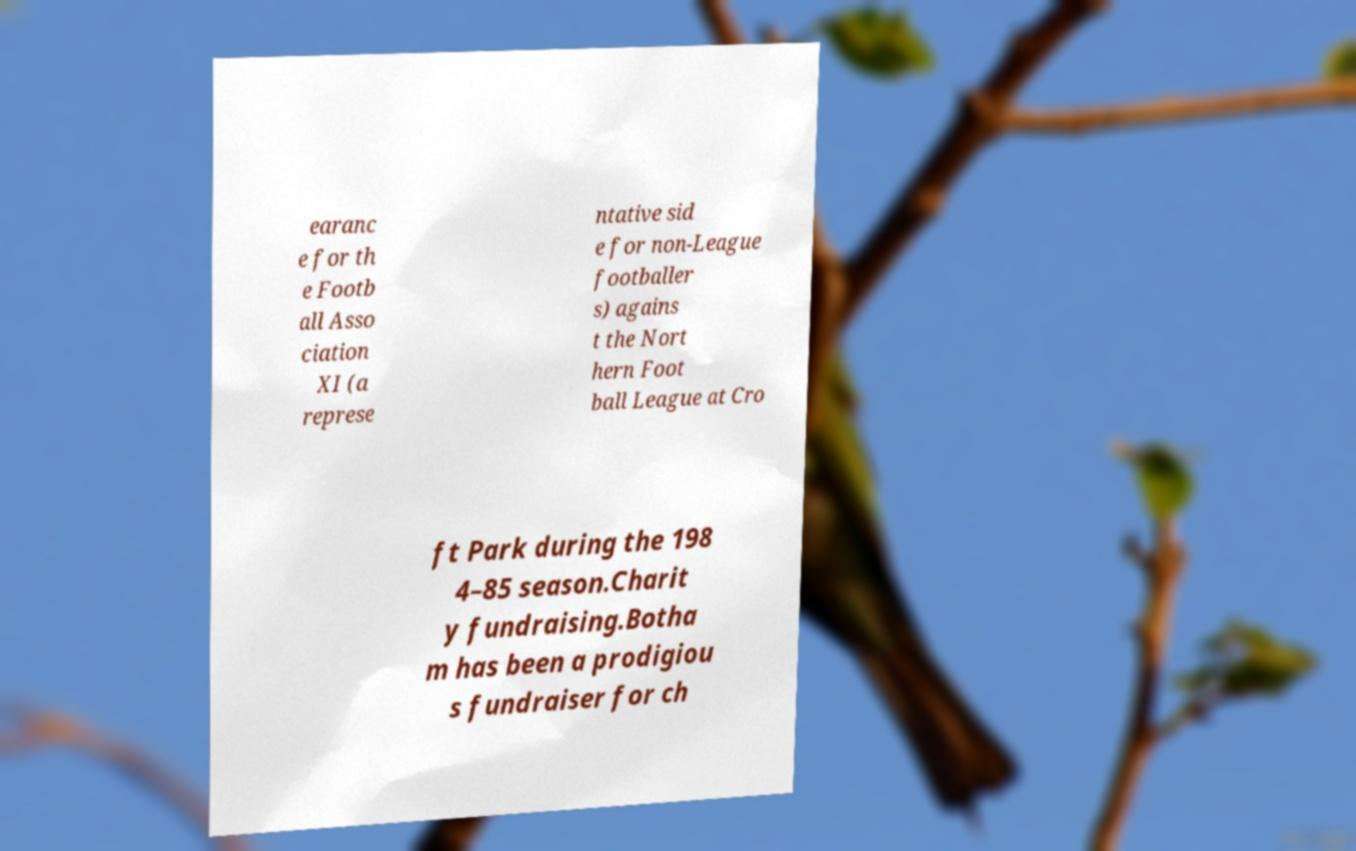Can you accurately transcribe the text from the provided image for me? earanc e for th e Footb all Asso ciation XI (a represe ntative sid e for non-League footballer s) agains t the Nort hern Foot ball League at Cro ft Park during the 198 4–85 season.Charit y fundraising.Botha m has been a prodigiou s fundraiser for ch 